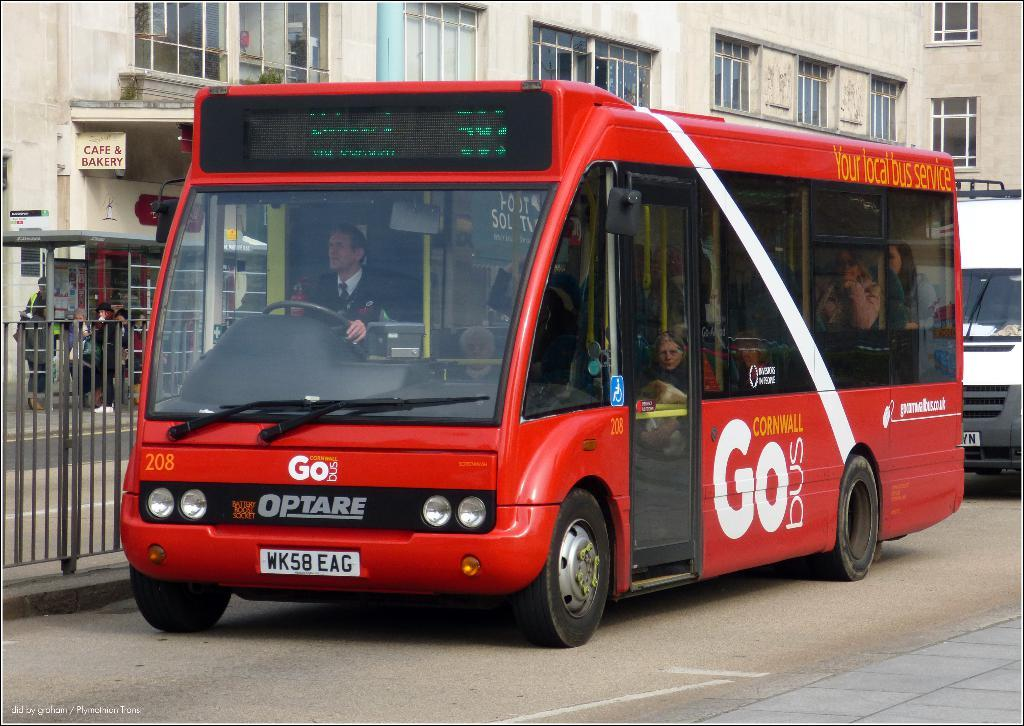What can be seen on the road in the image? There are vehicles on the road in the image. What type of vehicle is carrying people in the image? There are people seated in a bus in the image. What is visible in the background of the image? There is a fence, buildings, and a hoarding visible in the background of the image. How many steps does the hoarding take to measure its height in the image? The hoarding's height cannot be measured in steps, as it is a flat object in the image. Can you describe the breathing pattern of the people seated in the bus? There is no way to determine the breathing pattern of the people seated in the bus from the image. 